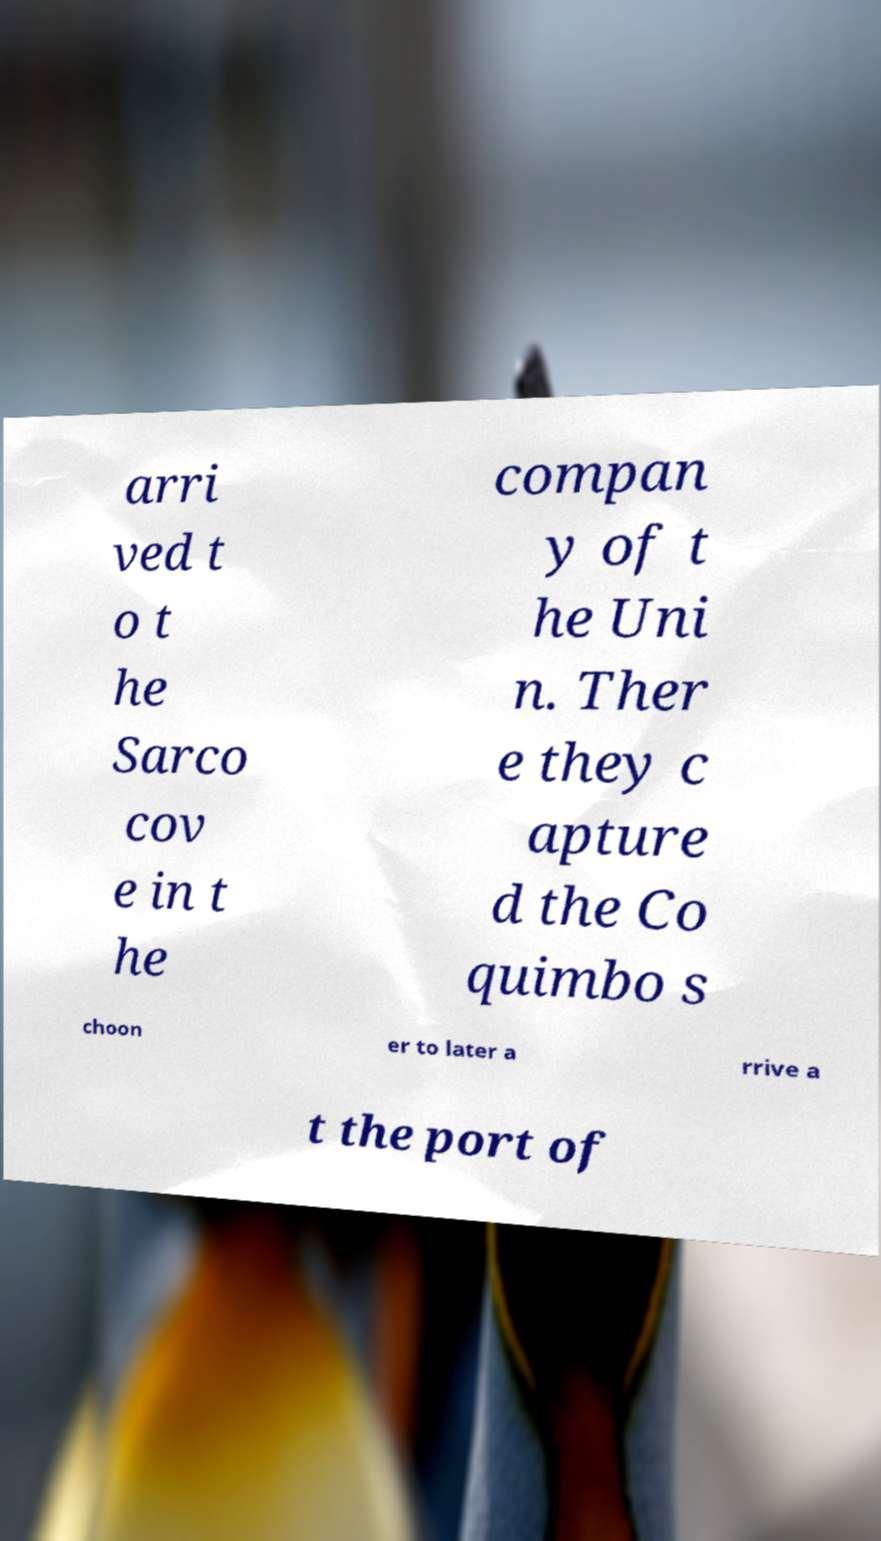What messages or text are displayed in this image? I need them in a readable, typed format. arri ved t o t he Sarco cov e in t he compan y of t he Uni n. Ther e they c apture d the Co quimbo s choon er to later a rrive a t the port of 